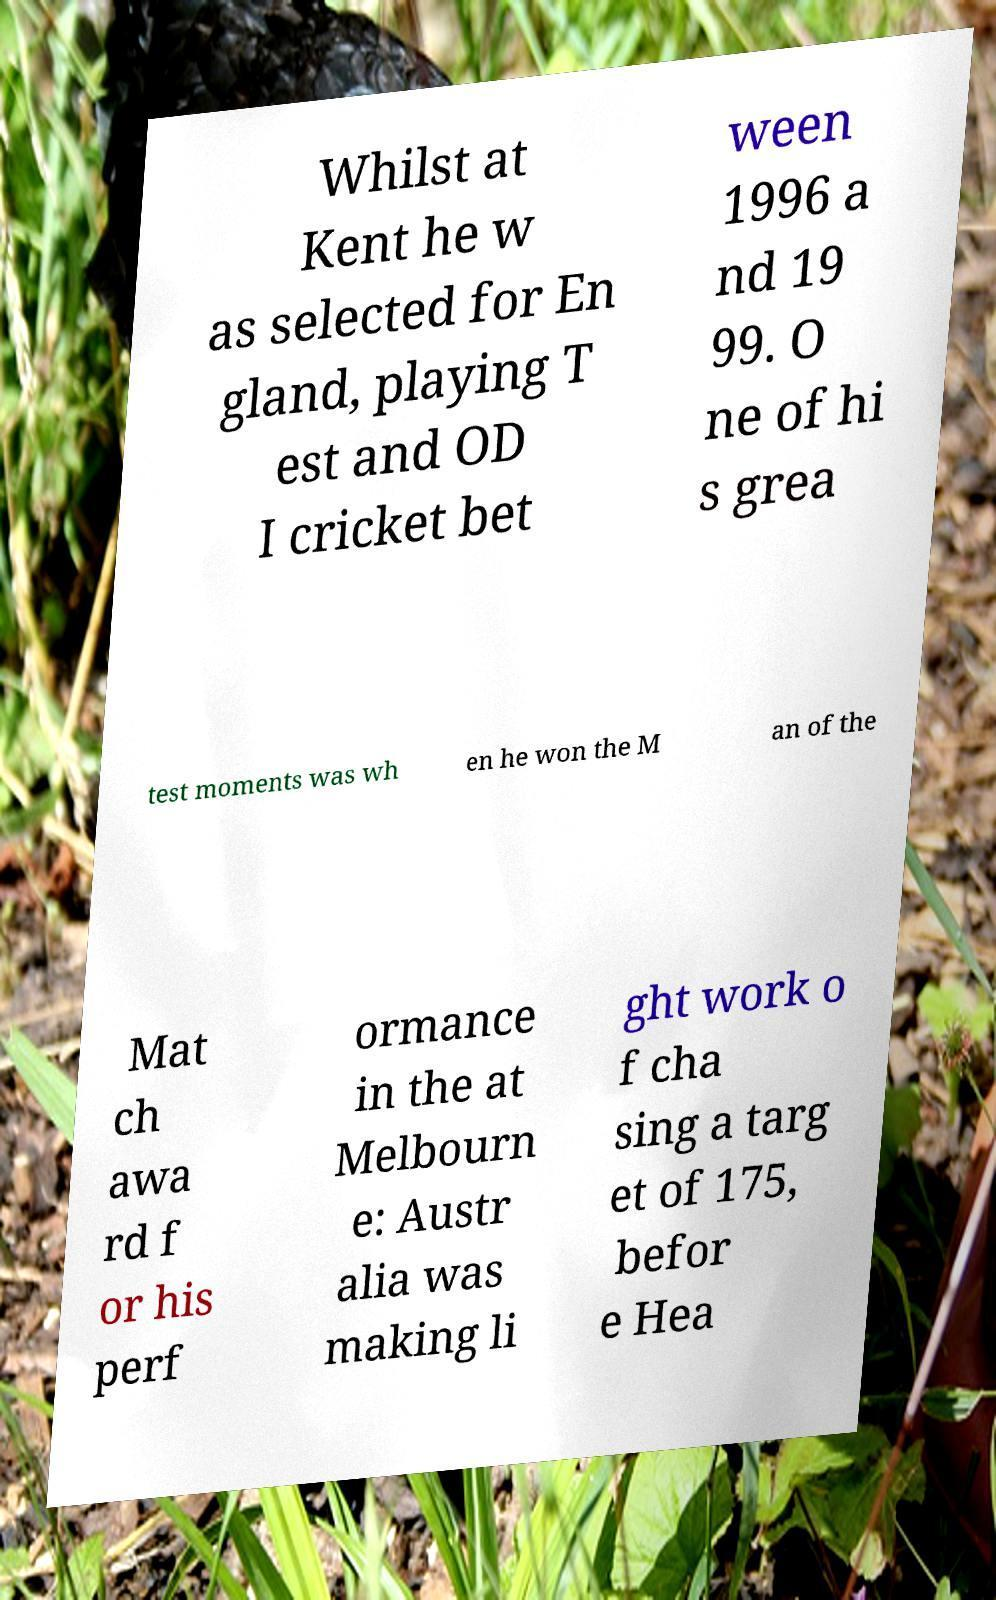Could you extract and type out the text from this image? Whilst at Kent he w as selected for En gland, playing T est and OD I cricket bet ween 1996 a nd 19 99. O ne of hi s grea test moments was wh en he won the M an of the Mat ch awa rd f or his perf ormance in the at Melbourn e: Austr alia was making li ght work o f cha sing a targ et of 175, befor e Hea 